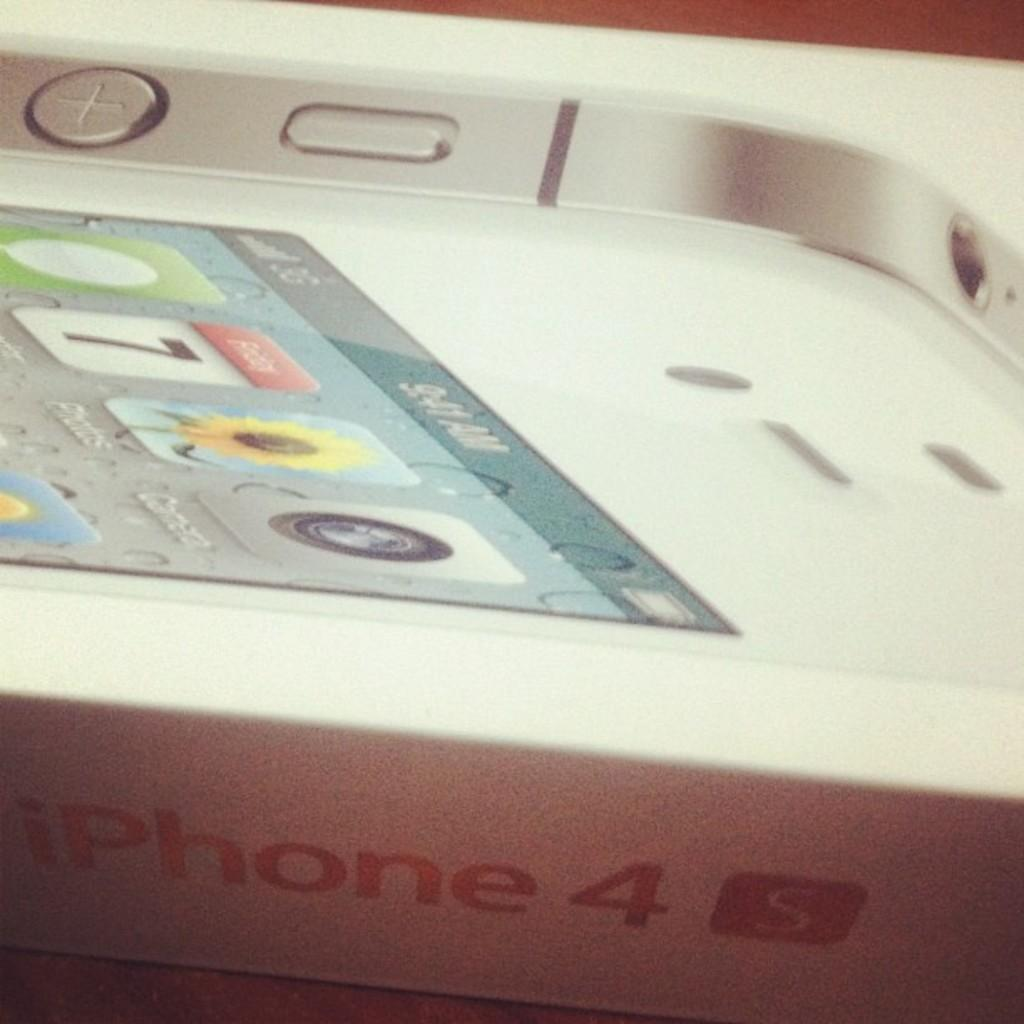Provide a one-sentence caption for the provided image. close up what looks like white iphone 4s box. 